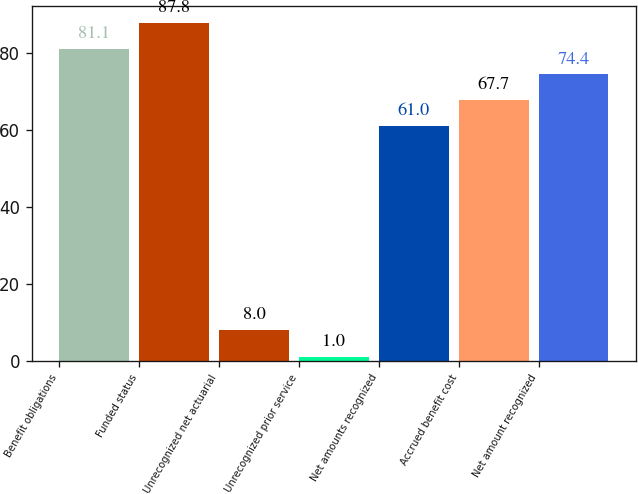<chart> <loc_0><loc_0><loc_500><loc_500><bar_chart><fcel>Benefit obligations<fcel>Funded status<fcel>Unrecognized net actuarial<fcel>Unrecognized prior service<fcel>Net amounts recognized<fcel>Accrued benefit cost<fcel>Net amount recognized<nl><fcel>81.1<fcel>87.8<fcel>8<fcel>1<fcel>61<fcel>67.7<fcel>74.4<nl></chart> 